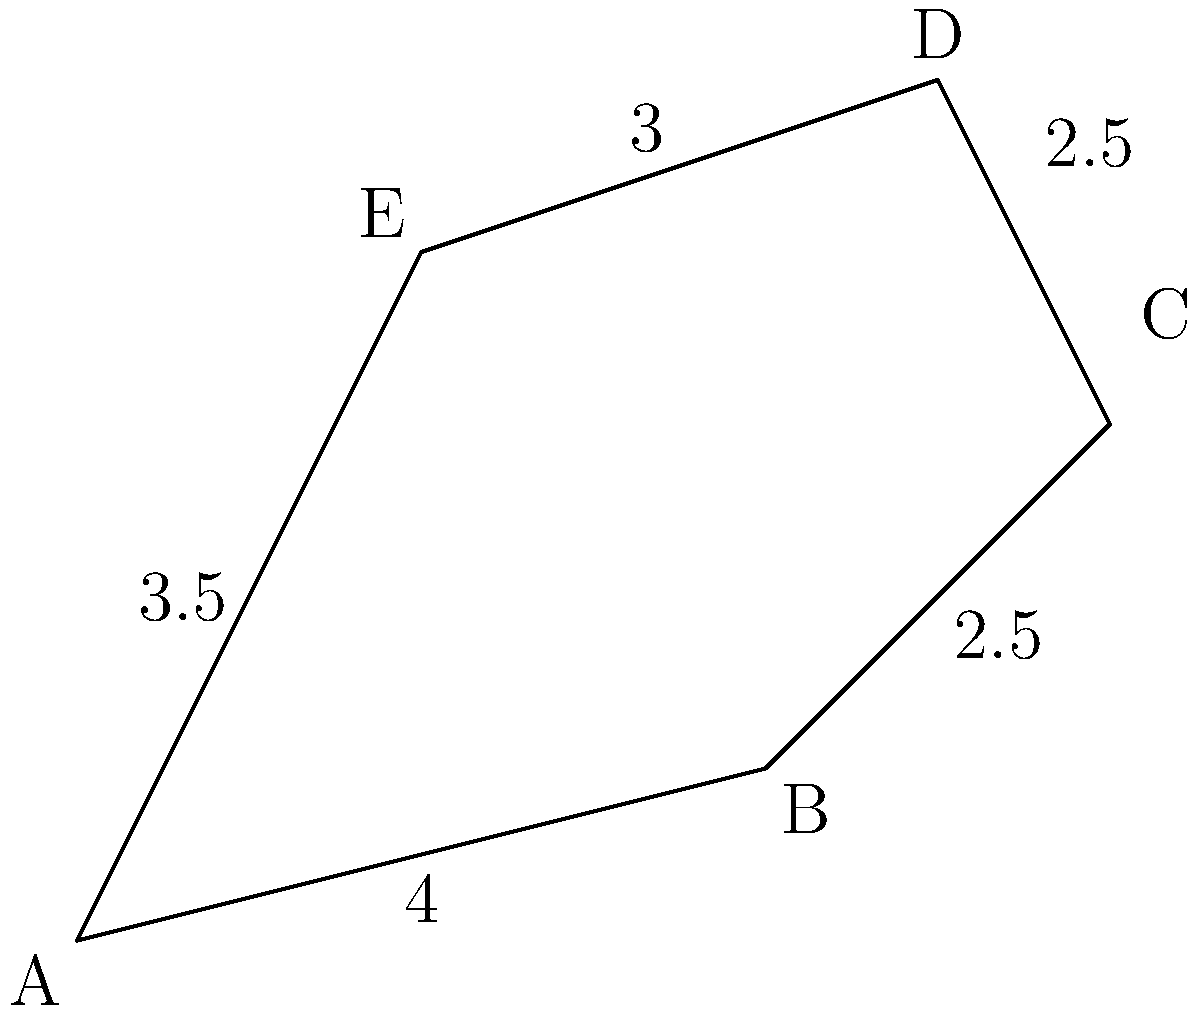As the head of the local history club, you're examining an irregularly shaped ancient settlement site. The site is represented by the polygon ABCDE in the diagram. Given the lengths of the sides (in kilometers) as shown, calculate the perimeter of the settlement site. To calculate the perimeter of the irregularly shaped ancient settlement site, we need to sum up the lengths of all sides of the polygon ABCDE. Let's break it down step by step:

1. Side AB: 4 km
2. Side BC: 2.5 km
3. Side CD: 2.5 km
4. Side DE: 3 km
5. Side EA: 3.5 km

Now, let's add all these lengths together:

$$\text{Perimeter} = AB + BC + CD + DE + EA$$
$$\text{Perimeter} = 4 + 2.5 + 2.5 + 3 + 3.5$$
$$\text{Perimeter} = 15.5 \text{ km}$$

Therefore, the perimeter of the ancient settlement site is 15.5 kilometers.
Answer: 15.5 km 